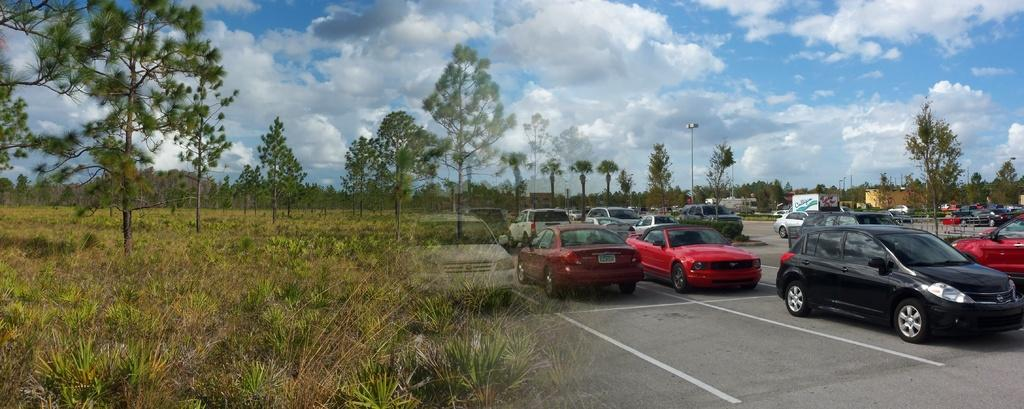What can be seen on the road in the image? There are vehicles on the road in the image. What type of vegetation is visible in the image? There is grass and trees visible in the image. What structure can be seen in the image? There is a light pole in the image. What is visible in the background of the image? The sky is visible in the background of the image. What can be seen in the sky? Clouds are present in the sky. What type of plant is growing on the light pole in the image? There are no plants growing on the light pole in the image. How many bananas can be seen hanging from the trees in the image? There are no bananas present in the image; only trees are visible. What is the zinc content of the vehicles in the image? The zinc content of the vehicles cannot be determined from the image. 